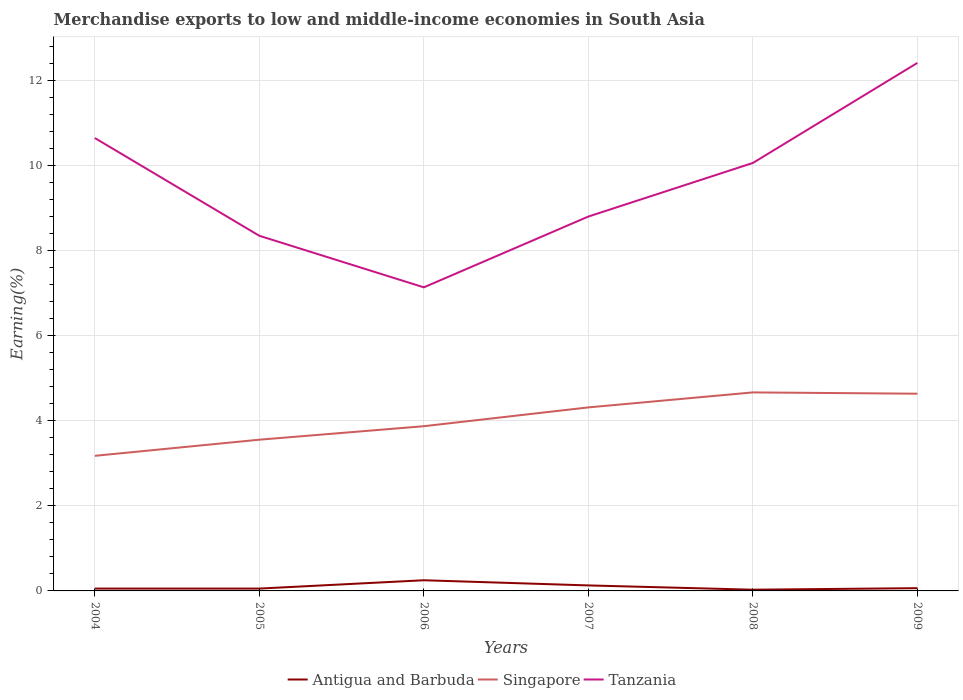How many different coloured lines are there?
Provide a short and direct response. 3. Does the line corresponding to Singapore intersect with the line corresponding to Tanzania?
Keep it short and to the point. No. Across all years, what is the maximum percentage of amount earned from merchandise exports in Tanzania?
Keep it short and to the point. 7.14. What is the total percentage of amount earned from merchandise exports in Singapore in the graph?
Your response must be concise. -0.38. What is the difference between the highest and the second highest percentage of amount earned from merchandise exports in Tanzania?
Provide a succinct answer. 5.28. Is the percentage of amount earned from merchandise exports in Tanzania strictly greater than the percentage of amount earned from merchandise exports in Antigua and Barbuda over the years?
Your answer should be very brief. No. Are the values on the major ticks of Y-axis written in scientific E-notation?
Make the answer very short. No. Does the graph contain any zero values?
Your response must be concise. No. What is the title of the graph?
Make the answer very short. Merchandise exports to low and middle-income economies in South Asia. Does "Other small states" appear as one of the legend labels in the graph?
Offer a very short reply. No. What is the label or title of the Y-axis?
Provide a short and direct response. Earning(%). What is the Earning(%) of Antigua and Barbuda in 2004?
Give a very brief answer. 0.06. What is the Earning(%) of Singapore in 2004?
Provide a succinct answer. 3.18. What is the Earning(%) in Tanzania in 2004?
Offer a very short reply. 10.65. What is the Earning(%) in Antigua and Barbuda in 2005?
Give a very brief answer. 0.06. What is the Earning(%) of Singapore in 2005?
Your answer should be compact. 3.55. What is the Earning(%) of Tanzania in 2005?
Provide a short and direct response. 8.35. What is the Earning(%) in Antigua and Barbuda in 2006?
Your answer should be very brief. 0.25. What is the Earning(%) of Singapore in 2006?
Give a very brief answer. 3.87. What is the Earning(%) of Tanzania in 2006?
Offer a very short reply. 7.14. What is the Earning(%) of Antigua and Barbuda in 2007?
Your answer should be compact. 0.13. What is the Earning(%) of Singapore in 2007?
Offer a very short reply. 4.31. What is the Earning(%) in Tanzania in 2007?
Offer a terse response. 8.8. What is the Earning(%) of Antigua and Barbuda in 2008?
Provide a succinct answer. 0.03. What is the Earning(%) of Singapore in 2008?
Keep it short and to the point. 4.67. What is the Earning(%) of Tanzania in 2008?
Your response must be concise. 10.06. What is the Earning(%) in Antigua and Barbuda in 2009?
Offer a very short reply. 0.06. What is the Earning(%) of Singapore in 2009?
Offer a terse response. 4.64. What is the Earning(%) of Tanzania in 2009?
Offer a very short reply. 12.41. Across all years, what is the maximum Earning(%) of Antigua and Barbuda?
Provide a succinct answer. 0.25. Across all years, what is the maximum Earning(%) in Singapore?
Offer a terse response. 4.67. Across all years, what is the maximum Earning(%) of Tanzania?
Offer a terse response. 12.41. Across all years, what is the minimum Earning(%) in Antigua and Barbuda?
Your answer should be very brief. 0.03. Across all years, what is the minimum Earning(%) of Singapore?
Offer a very short reply. 3.18. Across all years, what is the minimum Earning(%) in Tanzania?
Keep it short and to the point. 7.14. What is the total Earning(%) in Antigua and Barbuda in the graph?
Your answer should be compact. 0.58. What is the total Earning(%) of Singapore in the graph?
Make the answer very short. 24.22. What is the total Earning(%) in Tanzania in the graph?
Offer a terse response. 57.4. What is the difference between the Earning(%) of Antigua and Barbuda in 2004 and that in 2005?
Give a very brief answer. 0. What is the difference between the Earning(%) in Singapore in 2004 and that in 2005?
Provide a succinct answer. -0.38. What is the difference between the Earning(%) in Tanzania in 2004 and that in 2005?
Provide a short and direct response. 2.3. What is the difference between the Earning(%) of Antigua and Barbuda in 2004 and that in 2006?
Offer a very short reply. -0.2. What is the difference between the Earning(%) of Singapore in 2004 and that in 2006?
Offer a very short reply. -0.7. What is the difference between the Earning(%) of Tanzania in 2004 and that in 2006?
Make the answer very short. 3.51. What is the difference between the Earning(%) of Antigua and Barbuda in 2004 and that in 2007?
Offer a very short reply. -0.07. What is the difference between the Earning(%) in Singapore in 2004 and that in 2007?
Provide a succinct answer. -1.14. What is the difference between the Earning(%) in Tanzania in 2004 and that in 2007?
Keep it short and to the point. 1.85. What is the difference between the Earning(%) in Antigua and Barbuda in 2004 and that in 2008?
Provide a succinct answer. 0.03. What is the difference between the Earning(%) in Singapore in 2004 and that in 2008?
Provide a succinct answer. -1.49. What is the difference between the Earning(%) of Tanzania in 2004 and that in 2008?
Keep it short and to the point. 0.59. What is the difference between the Earning(%) of Antigua and Barbuda in 2004 and that in 2009?
Your answer should be compact. -0.01. What is the difference between the Earning(%) in Singapore in 2004 and that in 2009?
Offer a very short reply. -1.46. What is the difference between the Earning(%) in Tanzania in 2004 and that in 2009?
Offer a terse response. -1.77. What is the difference between the Earning(%) in Antigua and Barbuda in 2005 and that in 2006?
Your response must be concise. -0.2. What is the difference between the Earning(%) of Singapore in 2005 and that in 2006?
Your answer should be compact. -0.32. What is the difference between the Earning(%) of Tanzania in 2005 and that in 2006?
Ensure brevity in your answer.  1.21. What is the difference between the Earning(%) of Antigua and Barbuda in 2005 and that in 2007?
Offer a very short reply. -0.07. What is the difference between the Earning(%) of Singapore in 2005 and that in 2007?
Your answer should be compact. -0.76. What is the difference between the Earning(%) in Tanzania in 2005 and that in 2007?
Make the answer very short. -0.45. What is the difference between the Earning(%) of Antigua and Barbuda in 2005 and that in 2008?
Offer a very short reply. 0.03. What is the difference between the Earning(%) of Singapore in 2005 and that in 2008?
Make the answer very short. -1.11. What is the difference between the Earning(%) of Tanzania in 2005 and that in 2008?
Offer a very short reply. -1.71. What is the difference between the Earning(%) of Antigua and Barbuda in 2005 and that in 2009?
Your response must be concise. -0.01. What is the difference between the Earning(%) in Singapore in 2005 and that in 2009?
Your response must be concise. -1.08. What is the difference between the Earning(%) of Tanzania in 2005 and that in 2009?
Make the answer very short. -4.06. What is the difference between the Earning(%) of Antigua and Barbuda in 2006 and that in 2007?
Keep it short and to the point. 0.12. What is the difference between the Earning(%) in Singapore in 2006 and that in 2007?
Provide a succinct answer. -0.44. What is the difference between the Earning(%) in Tanzania in 2006 and that in 2007?
Provide a short and direct response. -1.66. What is the difference between the Earning(%) in Antigua and Barbuda in 2006 and that in 2008?
Give a very brief answer. 0.22. What is the difference between the Earning(%) of Singapore in 2006 and that in 2008?
Offer a very short reply. -0.79. What is the difference between the Earning(%) of Tanzania in 2006 and that in 2008?
Provide a short and direct response. -2.92. What is the difference between the Earning(%) of Antigua and Barbuda in 2006 and that in 2009?
Provide a succinct answer. 0.19. What is the difference between the Earning(%) of Singapore in 2006 and that in 2009?
Your answer should be very brief. -0.76. What is the difference between the Earning(%) in Tanzania in 2006 and that in 2009?
Give a very brief answer. -5.28. What is the difference between the Earning(%) of Antigua and Barbuda in 2007 and that in 2008?
Ensure brevity in your answer.  0.1. What is the difference between the Earning(%) in Singapore in 2007 and that in 2008?
Give a very brief answer. -0.35. What is the difference between the Earning(%) in Tanzania in 2007 and that in 2008?
Give a very brief answer. -1.26. What is the difference between the Earning(%) in Antigua and Barbuda in 2007 and that in 2009?
Provide a succinct answer. 0.06. What is the difference between the Earning(%) in Singapore in 2007 and that in 2009?
Your response must be concise. -0.32. What is the difference between the Earning(%) in Tanzania in 2007 and that in 2009?
Your response must be concise. -3.61. What is the difference between the Earning(%) of Antigua and Barbuda in 2008 and that in 2009?
Ensure brevity in your answer.  -0.04. What is the difference between the Earning(%) in Singapore in 2008 and that in 2009?
Make the answer very short. 0.03. What is the difference between the Earning(%) in Tanzania in 2008 and that in 2009?
Keep it short and to the point. -2.35. What is the difference between the Earning(%) in Antigua and Barbuda in 2004 and the Earning(%) in Singapore in 2005?
Make the answer very short. -3.5. What is the difference between the Earning(%) of Antigua and Barbuda in 2004 and the Earning(%) of Tanzania in 2005?
Your response must be concise. -8.29. What is the difference between the Earning(%) of Singapore in 2004 and the Earning(%) of Tanzania in 2005?
Your response must be concise. -5.17. What is the difference between the Earning(%) in Antigua and Barbuda in 2004 and the Earning(%) in Singapore in 2006?
Provide a short and direct response. -3.82. What is the difference between the Earning(%) in Antigua and Barbuda in 2004 and the Earning(%) in Tanzania in 2006?
Your answer should be compact. -7.08. What is the difference between the Earning(%) in Singapore in 2004 and the Earning(%) in Tanzania in 2006?
Provide a succinct answer. -3.96. What is the difference between the Earning(%) in Antigua and Barbuda in 2004 and the Earning(%) in Singapore in 2007?
Provide a succinct answer. -4.26. What is the difference between the Earning(%) of Antigua and Barbuda in 2004 and the Earning(%) of Tanzania in 2007?
Offer a terse response. -8.75. What is the difference between the Earning(%) in Singapore in 2004 and the Earning(%) in Tanzania in 2007?
Offer a very short reply. -5.62. What is the difference between the Earning(%) in Antigua and Barbuda in 2004 and the Earning(%) in Singapore in 2008?
Your response must be concise. -4.61. What is the difference between the Earning(%) in Antigua and Barbuda in 2004 and the Earning(%) in Tanzania in 2008?
Keep it short and to the point. -10.01. What is the difference between the Earning(%) in Singapore in 2004 and the Earning(%) in Tanzania in 2008?
Keep it short and to the point. -6.88. What is the difference between the Earning(%) of Antigua and Barbuda in 2004 and the Earning(%) of Singapore in 2009?
Your answer should be very brief. -4.58. What is the difference between the Earning(%) in Antigua and Barbuda in 2004 and the Earning(%) in Tanzania in 2009?
Your response must be concise. -12.36. What is the difference between the Earning(%) of Singapore in 2004 and the Earning(%) of Tanzania in 2009?
Keep it short and to the point. -9.24. What is the difference between the Earning(%) in Antigua and Barbuda in 2005 and the Earning(%) in Singapore in 2006?
Ensure brevity in your answer.  -3.82. What is the difference between the Earning(%) in Antigua and Barbuda in 2005 and the Earning(%) in Tanzania in 2006?
Offer a very short reply. -7.08. What is the difference between the Earning(%) in Singapore in 2005 and the Earning(%) in Tanzania in 2006?
Offer a very short reply. -3.58. What is the difference between the Earning(%) in Antigua and Barbuda in 2005 and the Earning(%) in Singapore in 2007?
Make the answer very short. -4.26. What is the difference between the Earning(%) of Antigua and Barbuda in 2005 and the Earning(%) of Tanzania in 2007?
Ensure brevity in your answer.  -8.75. What is the difference between the Earning(%) in Singapore in 2005 and the Earning(%) in Tanzania in 2007?
Give a very brief answer. -5.25. What is the difference between the Earning(%) in Antigua and Barbuda in 2005 and the Earning(%) in Singapore in 2008?
Your answer should be very brief. -4.61. What is the difference between the Earning(%) of Antigua and Barbuda in 2005 and the Earning(%) of Tanzania in 2008?
Provide a short and direct response. -10.01. What is the difference between the Earning(%) of Singapore in 2005 and the Earning(%) of Tanzania in 2008?
Keep it short and to the point. -6.51. What is the difference between the Earning(%) of Antigua and Barbuda in 2005 and the Earning(%) of Singapore in 2009?
Ensure brevity in your answer.  -4.58. What is the difference between the Earning(%) of Antigua and Barbuda in 2005 and the Earning(%) of Tanzania in 2009?
Make the answer very short. -12.36. What is the difference between the Earning(%) of Singapore in 2005 and the Earning(%) of Tanzania in 2009?
Provide a succinct answer. -8.86. What is the difference between the Earning(%) of Antigua and Barbuda in 2006 and the Earning(%) of Singapore in 2007?
Make the answer very short. -4.06. What is the difference between the Earning(%) of Antigua and Barbuda in 2006 and the Earning(%) of Tanzania in 2007?
Your answer should be very brief. -8.55. What is the difference between the Earning(%) in Singapore in 2006 and the Earning(%) in Tanzania in 2007?
Keep it short and to the point. -4.93. What is the difference between the Earning(%) of Antigua and Barbuda in 2006 and the Earning(%) of Singapore in 2008?
Make the answer very short. -4.42. What is the difference between the Earning(%) of Antigua and Barbuda in 2006 and the Earning(%) of Tanzania in 2008?
Offer a terse response. -9.81. What is the difference between the Earning(%) of Singapore in 2006 and the Earning(%) of Tanzania in 2008?
Your answer should be compact. -6.19. What is the difference between the Earning(%) of Antigua and Barbuda in 2006 and the Earning(%) of Singapore in 2009?
Offer a very short reply. -4.39. What is the difference between the Earning(%) in Antigua and Barbuda in 2006 and the Earning(%) in Tanzania in 2009?
Provide a succinct answer. -12.16. What is the difference between the Earning(%) of Singapore in 2006 and the Earning(%) of Tanzania in 2009?
Keep it short and to the point. -8.54. What is the difference between the Earning(%) of Antigua and Barbuda in 2007 and the Earning(%) of Singapore in 2008?
Keep it short and to the point. -4.54. What is the difference between the Earning(%) of Antigua and Barbuda in 2007 and the Earning(%) of Tanzania in 2008?
Your answer should be compact. -9.93. What is the difference between the Earning(%) in Singapore in 2007 and the Earning(%) in Tanzania in 2008?
Offer a terse response. -5.75. What is the difference between the Earning(%) of Antigua and Barbuda in 2007 and the Earning(%) of Singapore in 2009?
Your answer should be very brief. -4.51. What is the difference between the Earning(%) in Antigua and Barbuda in 2007 and the Earning(%) in Tanzania in 2009?
Your answer should be compact. -12.28. What is the difference between the Earning(%) in Singapore in 2007 and the Earning(%) in Tanzania in 2009?
Give a very brief answer. -8.1. What is the difference between the Earning(%) in Antigua and Barbuda in 2008 and the Earning(%) in Singapore in 2009?
Offer a very short reply. -4.61. What is the difference between the Earning(%) in Antigua and Barbuda in 2008 and the Earning(%) in Tanzania in 2009?
Offer a very short reply. -12.38. What is the difference between the Earning(%) in Singapore in 2008 and the Earning(%) in Tanzania in 2009?
Your answer should be very brief. -7.75. What is the average Earning(%) in Antigua and Barbuda per year?
Provide a succinct answer. 0.1. What is the average Earning(%) in Singapore per year?
Make the answer very short. 4.04. What is the average Earning(%) of Tanzania per year?
Your answer should be very brief. 9.57. In the year 2004, what is the difference between the Earning(%) of Antigua and Barbuda and Earning(%) of Singapore?
Provide a succinct answer. -3.12. In the year 2004, what is the difference between the Earning(%) in Antigua and Barbuda and Earning(%) in Tanzania?
Provide a short and direct response. -10.59. In the year 2004, what is the difference between the Earning(%) of Singapore and Earning(%) of Tanzania?
Keep it short and to the point. -7.47. In the year 2005, what is the difference between the Earning(%) of Antigua and Barbuda and Earning(%) of Singapore?
Your answer should be compact. -3.5. In the year 2005, what is the difference between the Earning(%) of Antigua and Barbuda and Earning(%) of Tanzania?
Make the answer very short. -8.29. In the year 2005, what is the difference between the Earning(%) of Singapore and Earning(%) of Tanzania?
Offer a very short reply. -4.79. In the year 2006, what is the difference between the Earning(%) of Antigua and Barbuda and Earning(%) of Singapore?
Provide a short and direct response. -3.62. In the year 2006, what is the difference between the Earning(%) of Antigua and Barbuda and Earning(%) of Tanzania?
Provide a succinct answer. -6.89. In the year 2006, what is the difference between the Earning(%) of Singapore and Earning(%) of Tanzania?
Offer a terse response. -3.26. In the year 2007, what is the difference between the Earning(%) of Antigua and Barbuda and Earning(%) of Singapore?
Provide a short and direct response. -4.19. In the year 2007, what is the difference between the Earning(%) in Antigua and Barbuda and Earning(%) in Tanzania?
Give a very brief answer. -8.67. In the year 2007, what is the difference between the Earning(%) in Singapore and Earning(%) in Tanzania?
Offer a very short reply. -4.49. In the year 2008, what is the difference between the Earning(%) in Antigua and Barbuda and Earning(%) in Singapore?
Make the answer very short. -4.64. In the year 2008, what is the difference between the Earning(%) in Antigua and Barbuda and Earning(%) in Tanzania?
Offer a very short reply. -10.03. In the year 2008, what is the difference between the Earning(%) in Singapore and Earning(%) in Tanzania?
Your answer should be compact. -5.39. In the year 2009, what is the difference between the Earning(%) in Antigua and Barbuda and Earning(%) in Singapore?
Provide a succinct answer. -4.57. In the year 2009, what is the difference between the Earning(%) in Antigua and Barbuda and Earning(%) in Tanzania?
Make the answer very short. -12.35. In the year 2009, what is the difference between the Earning(%) of Singapore and Earning(%) of Tanzania?
Provide a short and direct response. -7.78. What is the ratio of the Earning(%) of Singapore in 2004 to that in 2005?
Provide a succinct answer. 0.89. What is the ratio of the Earning(%) in Tanzania in 2004 to that in 2005?
Your answer should be very brief. 1.28. What is the ratio of the Earning(%) in Antigua and Barbuda in 2004 to that in 2006?
Give a very brief answer. 0.22. What is the ratio of the Earning(%) of Singapore in 2004 to that in 2006?
Your answer should be compact. 0.82. What is the ratio of the Earning(%) in Tanzania in 2004 to that in 2006?
Offer a very short reply. 1.49. What is the ratio of the Earning(%) in Antigua and Barbuda in 2004 to that in 2007?
Provide a succinct answer. 0.43. What is the ratio of the Earning(%) of Singapore in 2004 to that in 2007?
Provide a succinct answer. 0.74. What is the ratio of the Earning(%) of Tanzania in 2004 to that in 2007?
Provide a short and direct response. 1.21. What is the ratio of the Earning(%) of Antigua and Barbuda in 2004 to that in 2008?
Keep it short and to the point. 1.91. What is the ratio of the Earning(%) of Singapore in 2004 to that in 2008?
Keep it short and to the point. 0.68. What is the ratio of the Earning(%) of Tanzania in 2004 to that in 2008?
Your answer should be compact. 1.06. What is the ratio of the Earning(%) of Antigua and Barbuda in 2004 to that in 2009?
Make the answer very short. 0.86. What is the ratio of the Earning(%) in Singapore in 2004 to that in 2009?
Ensure brevity in your answer.  0.69. What is the ratio of the Earning(%) in Tanzania in 2004 to that in 2009?
Provide a short and direct response. 0.86. What is the ratio of the Earning(%) in Antigua and Barbuda in 2005 to that in 2006?
Your answer should be very brief. 0.22. What is the ratio of the Earning(%) in Singapore in 2005 to that in 2006?
Your answer should be compact. 0.92. What is the ratio of the Earning(%) of Tanzania in 2005 to that in 2006?
Offer a terse response. 1.17. What is the ratio of the Earning(%) of Antigua and Barbuda in 2005 to that in 2007?
Your answer should be compact. 0.43. What is the ratio of the Earning(%) of Singapore in 2005 to that in 2007?
Your response must be concise. 0.82. What is the ratio of the Earning(%) in Tanzania in 2005 to that in 2007?
Your response must be concise. 0.95. What is the ratio of the Earning(%) in Antigua and Barbuda in 2005 to that in 2008?
Give a very brief answer. 1.91. What is the ratio of the Earning(%) in Singapore in 2005 to that in 2008?
Offer a terse response. 0.76. What is the ratio of the Earning(%) of Tanzania in 2005 to that in 2008?
Provide a succinct answer. 0.83. What is the ratio of the Earning(%) in Antigua and Barbuda in 2005 to that in 2009?
Make the answer very short. 0.85. What is the ratio of the Earning(%) in Singapore in 2005 to that in 2009?
Your answer should be compact. 0.77. What is the ratio of the Earning(%) of Tanzania in 2005 to that in 2009?
Provide a short and direct response. 0.67. What is the ratio of the Earning(%) of Antigua and Barbuda in 2006 to that in 2007?
Give a very brief answer. 1.94. What is the ratio of the Earning(%) of Singapore in 2006 to that in 2007?
Your response must be concise. 0.9. What is the ratio of the Earning(%) in Tanzania in 2006 to that in 2007?
Make the answer very short. 0.81. What is the ratio of the Earning(%) in Antigua and Barbuda in 2006 to that in 2008?
Your response must be concise. 8.7. What is the ratio of the Earning(%) of Singapore in 2006 to that in 2008?
Keep it short and to the point. 0.83. What is the ratio of the Earning(%) in Tanzania in 2006 to that in 2008?
Give a very brief answer. 0.71. What is the ratio of the Earning(%) in Antigua and Barbuda in 2006 to that in 2009?
Make the answer very short. 3.89. What is the ratio of the Earning(%) in Singapore in 2006 to that in 2009?
Your response must be concise. 0.84. What is the ratio of the Earning(%) in Tanzania in 2006 to that in 2009?
Your response must be concise. 0.57. What is the ratio of the Earning(%) in Antigua and Barbuda in 2007 to that in 2008?
Provide a succinct answer. 4.48. What is the ratio of the Earning(%) of Singapore in 2007 to that in 2008?
Give a very brief answer. 0.92. What is the ratio of the Earning(%) in Tanzania in 2007 to that in 2008?
Provide a short and direct response. 0.87. What is the ratio of the Earning(%) in Antigua and Barbuda in 2007 to that in 2009?
Ensure brevity in your answer.  2. What is the ratio of the Earning(%) in Singapore in 2007 to that in 2009?
Your answer should be very brief. 0.93. What is the ratio of the Earning(%) in Tanzania in 2007 to that in 2009?
Give a very brief answer. 0.71. What is the ratio of the Earning(%) in Antigua and Barbuda in 2008 to that in 2009?
Offer a very short reply. 0.45. What is the ratio of the Earning(%) in Singapore in 2008 to that in 2009?
Give a very brief answer. 1.01. What is the ratio of the Earning(%) of Tanzania in 2008 to that in 2009?
Offer a very short reply. 0.81. What is the difference between the highest and the second highest Earning(%) in Antigua and Barbuda?
Ensure brevity in your answer.  0.12. What is the difference between the highest and the second highest Earning(%) in Singapore?
Offer a terse response. 0.03. What is the difference between the highest and the second highest Earning(%) of Tanzania?
Offer a very short reply. 1.77. What is the difference between the highest and the lowest Earning(%) in Antigua and Barbuda?
Provide a short and direct response. 0.22. What is the difference between the highest and the lowest Earning(%) of Singapore?
Offer a terse response. 1.49. What is the difference between the highest and the lowest Earning(%) of Tanzania?
Your response must be concise. 5.28. 